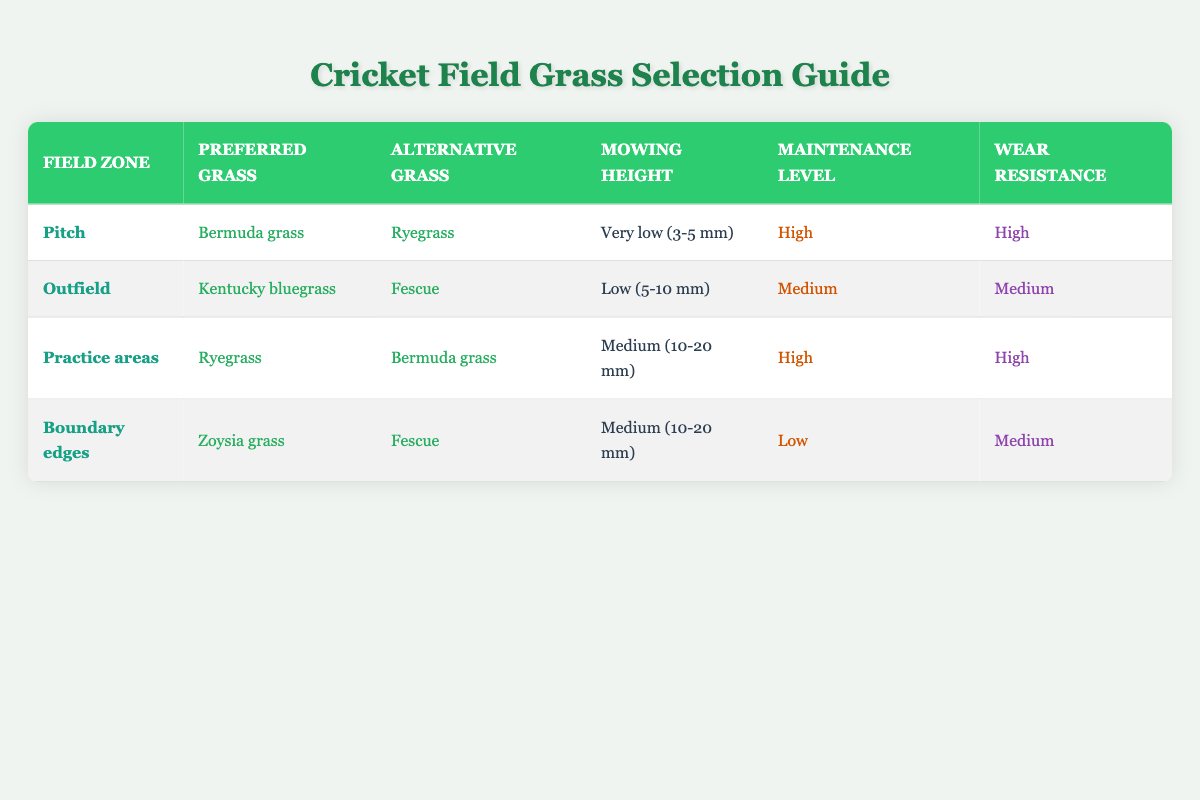What is the preferred grass for the Pitch zone? The table shows that the preferred grass for the Pitch zone is Bermuda grass.
Answer: Bermuda grass Which grass species has a medium wear resistance in the Outfield? The Outfield zone has Kentucky bluegrass as the preferred grass and Fescue as the alternative grass, with medium wear resistance listed for both.
Answer: Kentucky bluegrass and Fescue What is the mowing height for Practice areas? According to the table, the mowing height recommended for Practice areas is Medium (10-20 mm).
Answer: Medium (10-20 mm) Is Zoysia grass recommended for high maintenance areas? The table indicates that Zoysia grass is preferred for Boundary edges, which have a low maintenance level. Thus, it is not recommended for high maintenance areas.
Answer: No What is the average maintenance level for the grass species recommended for the Pitch and Practice areas? The Pitch zone requires a High maintenance level, while the Practice areas also require a High maintenance level. Since both are the same category, the average maintenance level is High.
Answer: High What is the relationship between mowing height and maintenance level for the Outfield? The Outfield has a mowing height of Low (5-10 mm) and a Medium maintenance level. Typically, a lower mowing height can lead to a higher maintenance requirement, but in this case, it is balanced at Medium maintenance.
Answer: Low mowing height, Medium maintenance level Which zone has the highest recovery rate based on the grass species recommended? Both Pitch and Practice areas recommend grass species with high recovery rates. Since both zones support high recovery rates for their preferred grasses, they share this character.
Answer: Pitch and Practice areas Which grass species is the alternative for Boundary edges? The table lists Fescue as the alternative grass for the Boundary edges zone.
Answer: Fescue What is the least preferred grass for the Practice areas? Bermuda grass is an alternative grass for Practice areas, while Ryegrass is the preferred one. Since alternative grasses are considered less favored, Bermuda grass is the least preferred.
Answer: Bermuda grass 